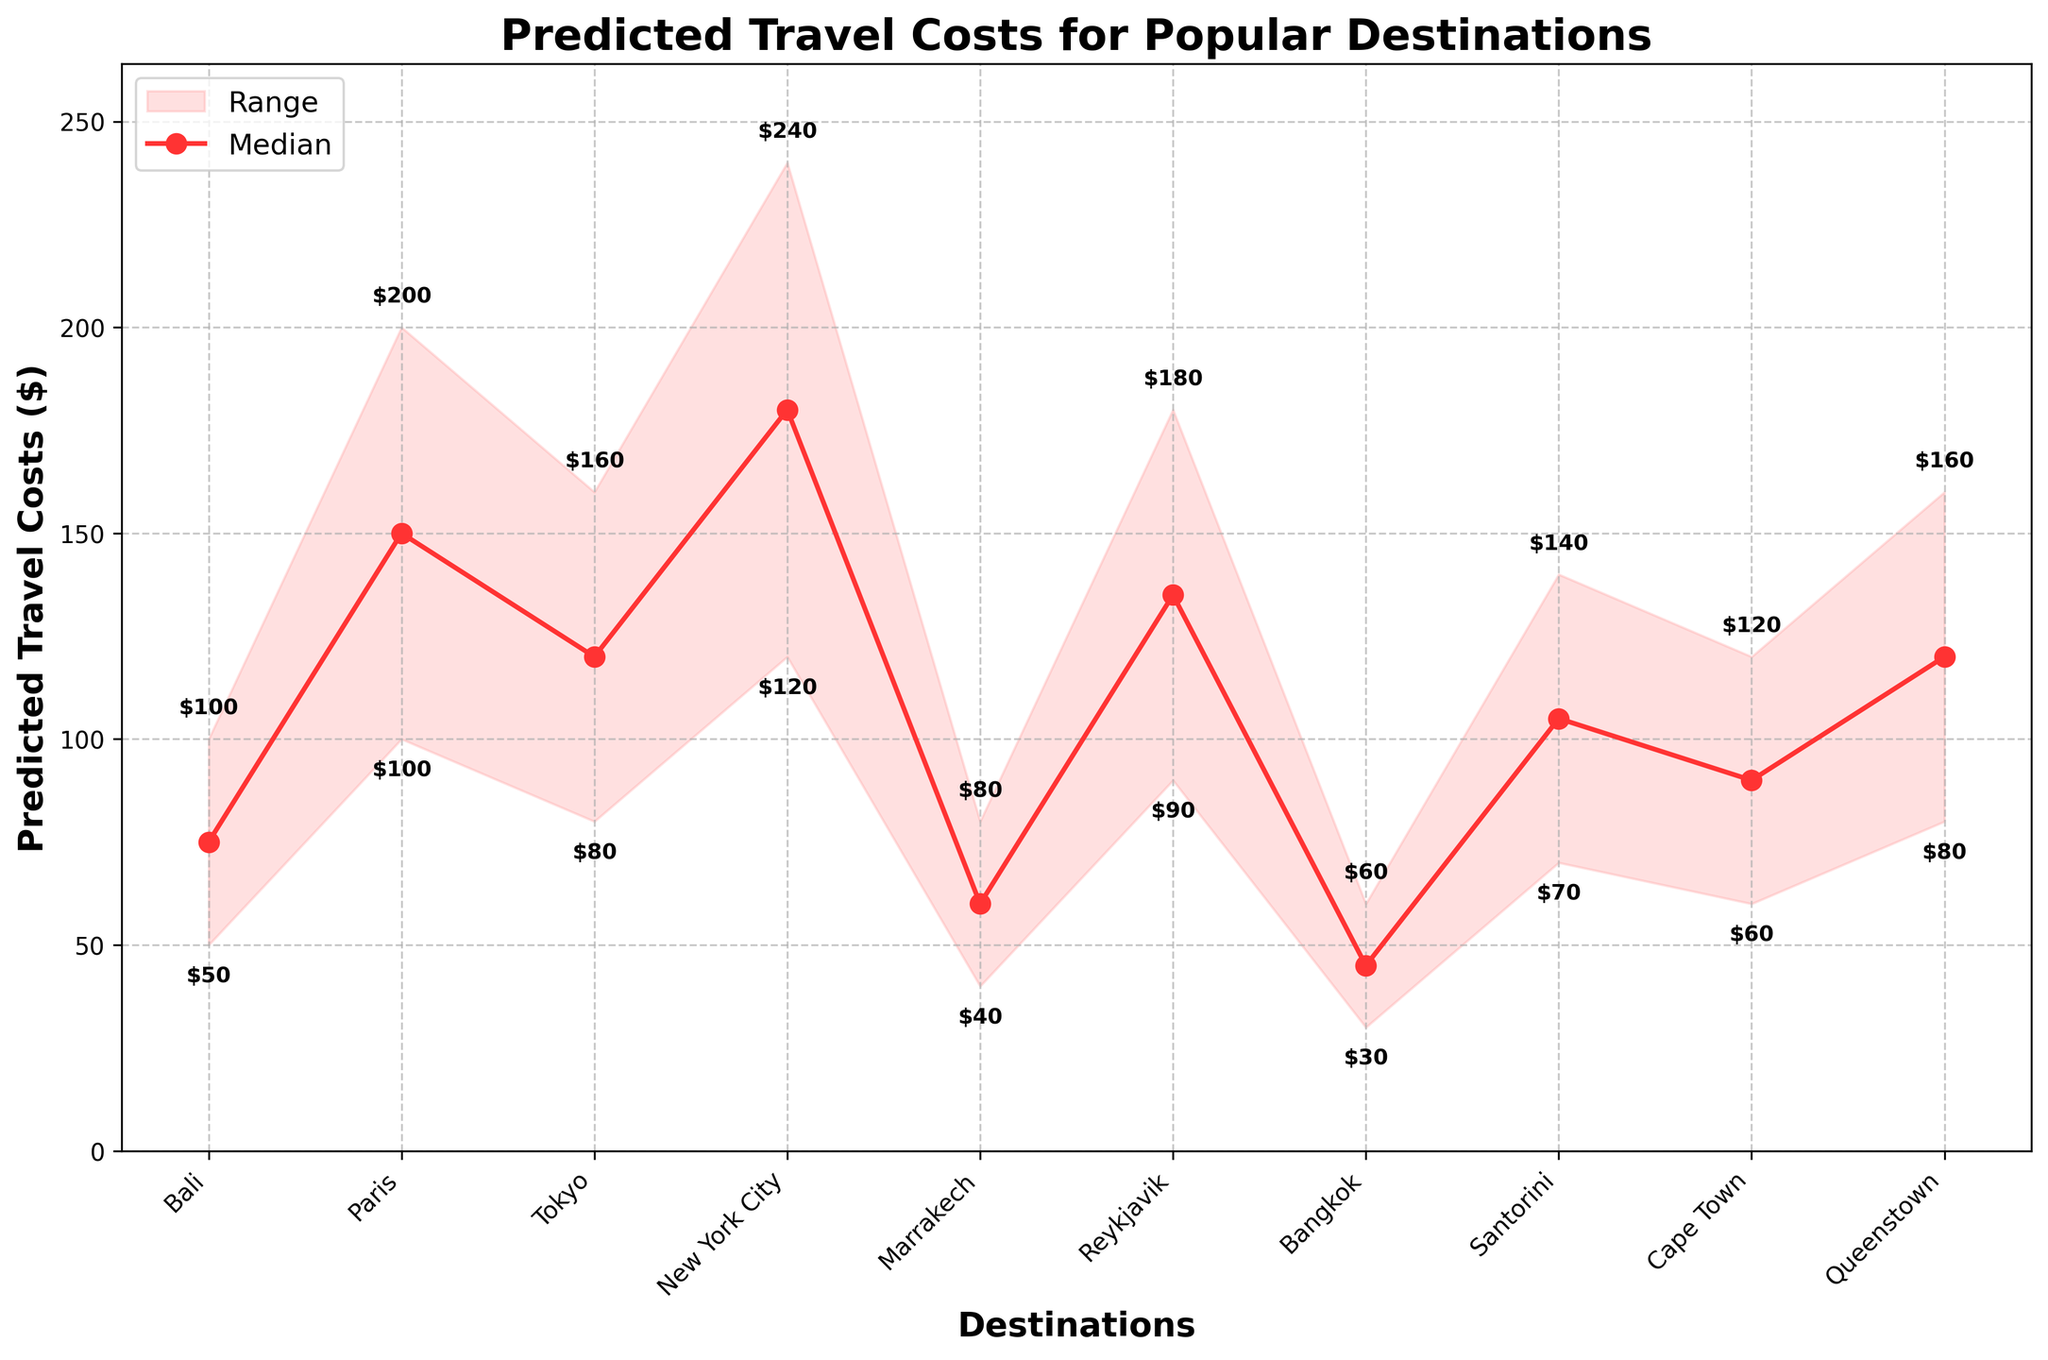What's the title of the chart? The title is typically found at the top of the chart where it conveys the main topic being illustrated. In this chart, the title reads "Predicted Travel Costs for Popular Destinations", which indicates the content being visualized is the predicted costs associated with traveling to various popular destinations.
Answer: Predicted Travel Costs for Popular Destinations Which destination has the highest median predicted travel cost? To determine the highest median predicted travel cost, scan the median values for each destination. The median value for NYC is $180, which is the highest among all destinations.
Answer: New York City What is the range of predicted travel costs for Tokyo? To find the range, subtract the low value from the high value for Tokyo. This would be 160 - 80 = 80.
Answer: 80 What is the median predicted travel cost for Reykjavik? Locate Reykjavik on the x-axis and check the median value plotted above it, which is shown as a red marker. The median value for Reykjavik is $135.
Answer: $135 Which destination has the lowest 'Low' predicted travel cost, and what's the value? Identify the smallest 'Low' value among all destinations. The lowest 'Low' predicted travel cost is $30 for Bangkok.
Answer: Bangkok, $30 How many destinations have a median travel cost below $100? Count the number of destinations with median values below $100. These are Bali ($75), Marrakech ($60), Bangkok ($45), Cape Town ($90). So, there are 4 destinations.
Answer: 4 Which destination has the widest range of predicted travel costs? Determine the difference between the high and low values for each destination, and find the greatest difference. NYC has the widest range with a difference of 240 - 120 = 120.
Answer: New York City How much higher is the high predicted travel cost for Paris compared to Bali? Find the high values for both Paris ($200) and Bali ($100), and then subtract the high value of Bali from that of Paris. So, $200 - $100 = $100.
Answer: $100 What's the median difference in travel costs between Santorini and Bangkok? Identify the median values for Santorini ($105) and Bangkok ($45), then subtract the median for Bangkok from that of Santorini. So, $105 - $45 = $60.
Answer: $60 What are the low and high values for Cape Town, and what is their average? Locate Cape Town and note its low ($60) and high ($120) values. To find the average, sum these two values and divide by 2: (60 + 120) / 2 = 90.
Answer: Low: $60, High: $120, Average: $90 